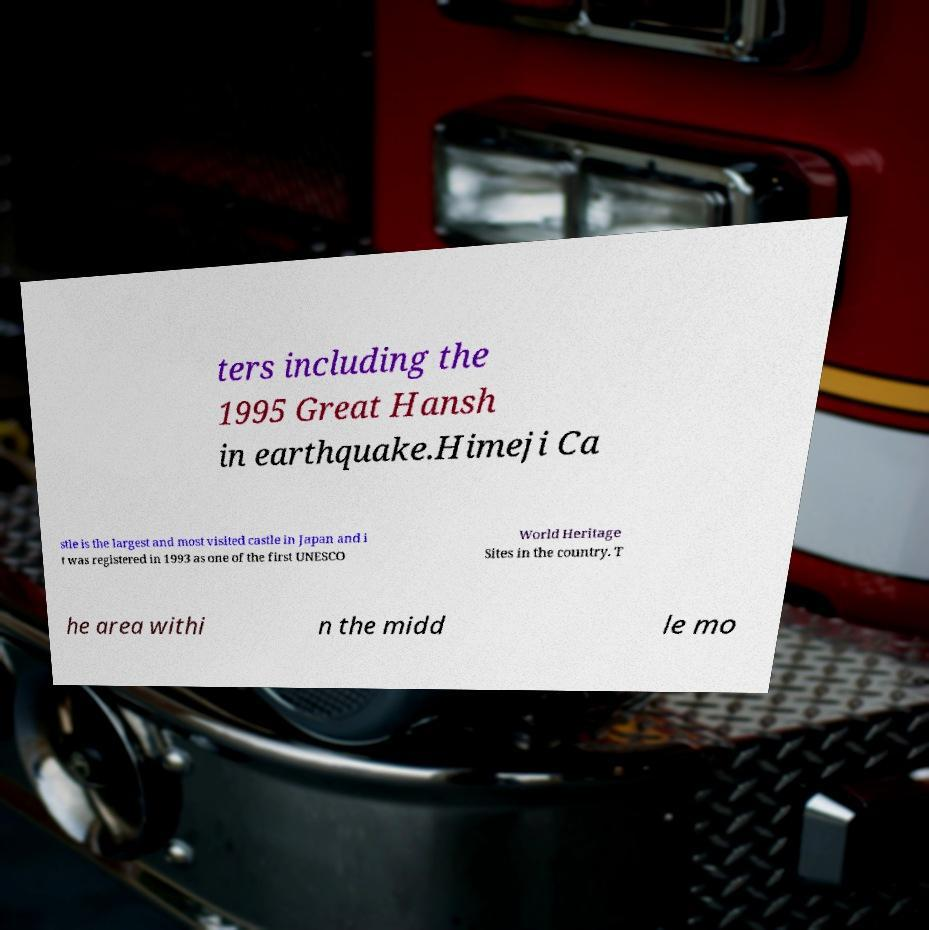I need the written content from this picture converted into text. Can you do that? ters including the 1995 Great Hansh in earthquake.Himeji Ca stle is the largest and most visited castle in Japan and i t was registered in 1993 as one of the first UNESCO World Heritage Sites in the country. T he area withi n the midd le mo 